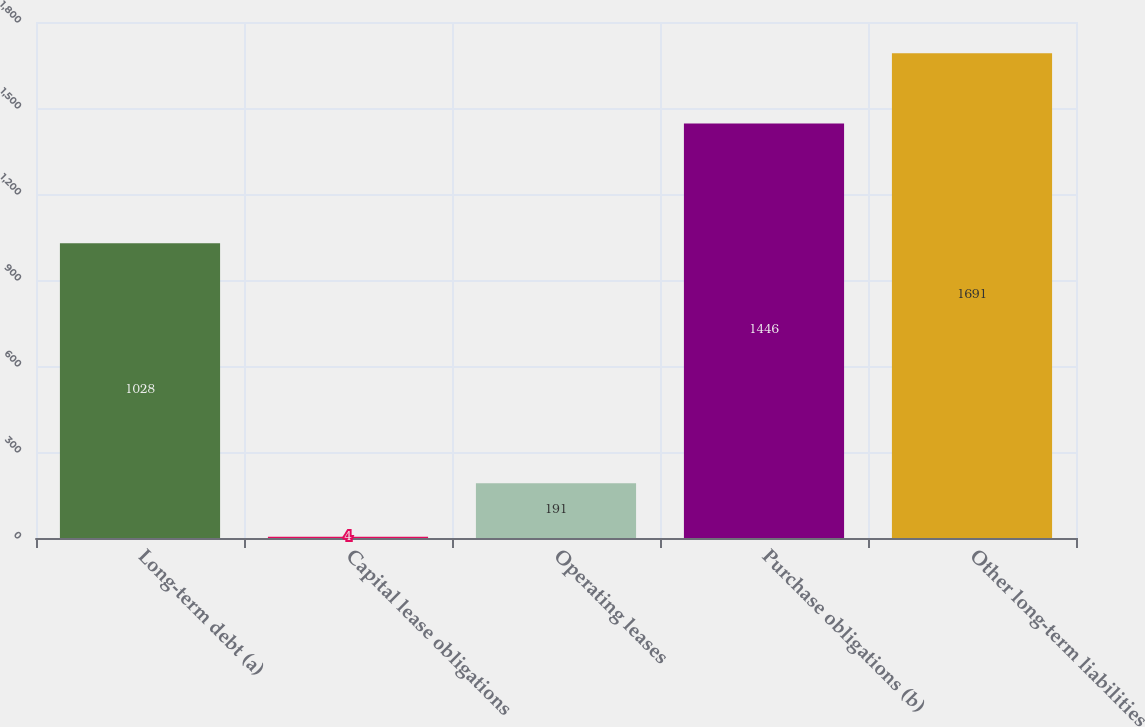Convert chart. <chart><loc_0><loc_0><loc_500><loc_500><bar_chart><fcel>Long-term debt (a)<fcel>Capital lease obligations<fcel>Operating leases<fcel>Purchase obligations (b)<fcel>Other long-term liabilities<nl><fcel>1028<fcel>4<fcel>191<fcel>1446<fcel>1691<nl></chart> 